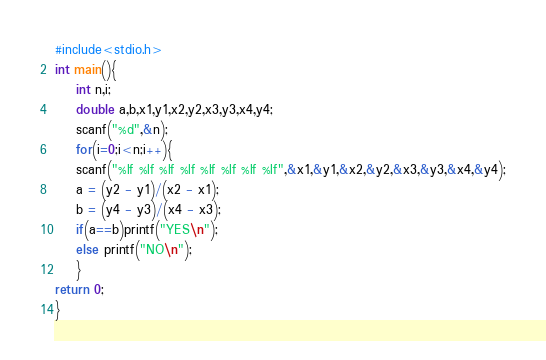Convert code to text. <code><loc_0><loc_0><loc_500><loc_500><_C_>#include<stdio.h>
int main(){
	int n,i;
	double a,b,x1,y1,x2,y2,x3,y3,x4,y4;
	scanf("%d",&n);
	for(i=0;i<n;i++){
	scanf("%lf %lf %lf %lf %lf %lf %lf %lf",&x1,&y1,&x2,&y2,&x3,&y3,&x4,&y4);
	a = (y2 - y1)/(x2 - x1);
	b = (y4 - y3)/(x4 - x3);
	if(a==b)printf("YES\n");
	else printf("NO\n");
	}
return 0;
}</code> 